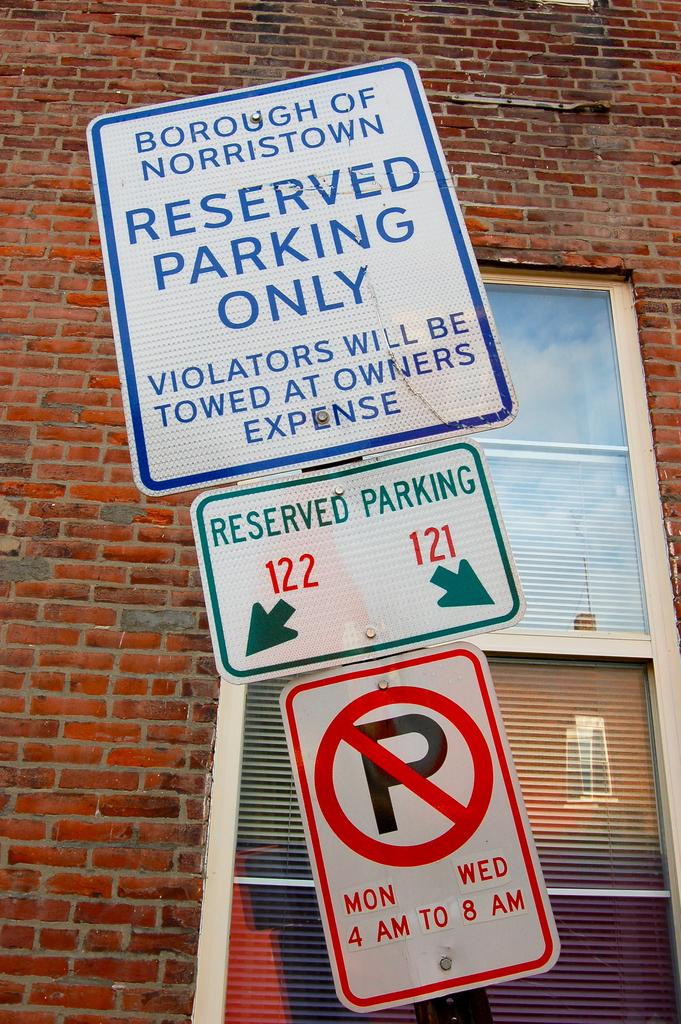<image>
Create a compact narrative representing the image presented. A sign on a pole before a building stresses greatly that the parking is for reserved people only. 